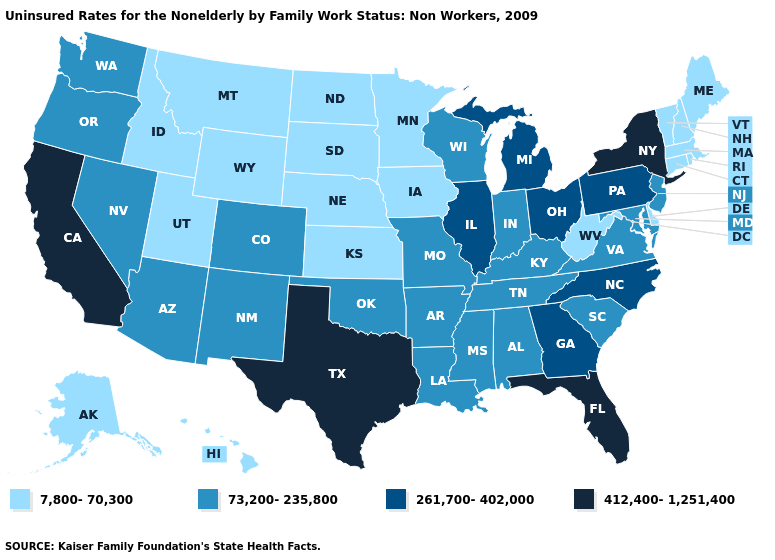Is the legend a continuous bar?
Short answer required. No. What is the value of Missouri?
Concise answer only. 73,200-235,800. Among the states that border New Jersey , which have the lowest value?
Give a very brief answer. Delaware. What is the value of Michigan?
Short answer required. 261,700-402,000. Name the states that have a value in the range 73,200-235,800?
Write a very short answer. Alabama, Arizona, Arkansas, Colorado, Indiana, Kentucky, Louisiana, Maryland, Mississippi, Missouri, Nevada, New Jersey, New Mexico, Oklahoma, Oregon, South Carolina, Tennessee, Virginia, Washington, Wisconsin. Among the states that border Texas , which have the lowest value?
Give a very brief answer. Arkansas, Louisiana, New Mexico, Oklahoma. Does West Virginia have the lowest value in the South?
Answer briefly. Yes. Which states hav the highest value in the MidWest?
Quick response, please. Illinois, Michigan, Ohio. What is the highest value in states that border Illinois?
Concise answer only. 73,200-235,800. What is the highest value in the USA?
Answer briefly. 412,400-1,251,400. Name the states that have a value in the range 261,700-402,000?
Be succinct. Georgia, Illinois, Michigan, North Carolina, Ohio, Pennsylvania. Which states have the lowest value in the MidWest?
Short answer required. Iowa, Kansas, Minnesota, Nebraska, North Dakota, South Dakota. What is the lowest value in states that border Tennessee?
Answer briefly. 73,200-235,800. Does Texas have the highest value in the USA?
Quick response, please. Yes. 